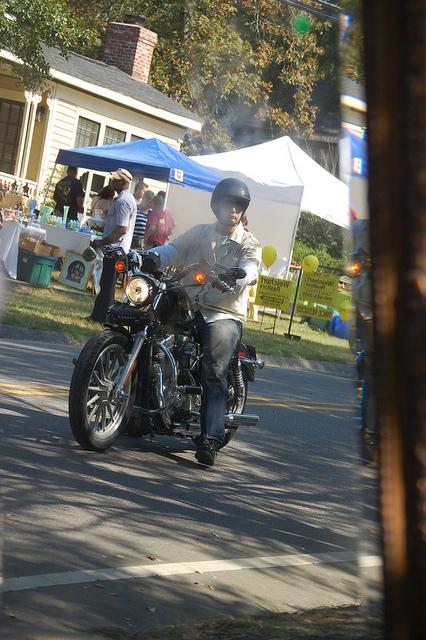Is there smoke in the air?
Keep it brief. Yes. Is this rider wearing a helmet?
Be succinct. Yes. Is he driving through a downtown street?
Give a very brief answer. No. 